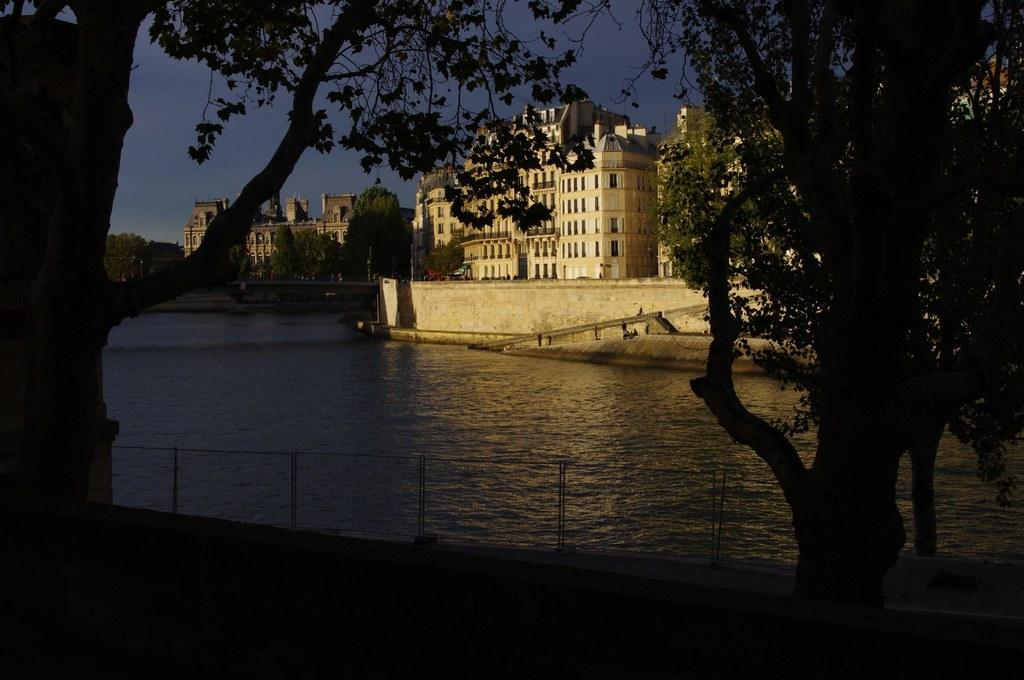What type of barrier can be seen in the image? There is a fence in the image. What natural element is visible in the image? There is water visible in the image. What type of vegetation is present in the image? There are trees in the image. What type of man-made structures are visible in the image? There are buildings in the image. What type of lighting infrastructure is present in the image? There are light poles in the image. What type of transportation is visible in the image? There are vehicles on the road in the image. What part of the natural environment is visible in the image? The sky is visible in the image. What might be the location of the image, based on the presence of water? The image may have been taken near a lake, given the presence of water. What type of kettle is visible in the image? There is no kettle present in the image. What type of honey is being produced by the trees in the image? There is no honey production by the trees in the image, as trees do not produce honey. 